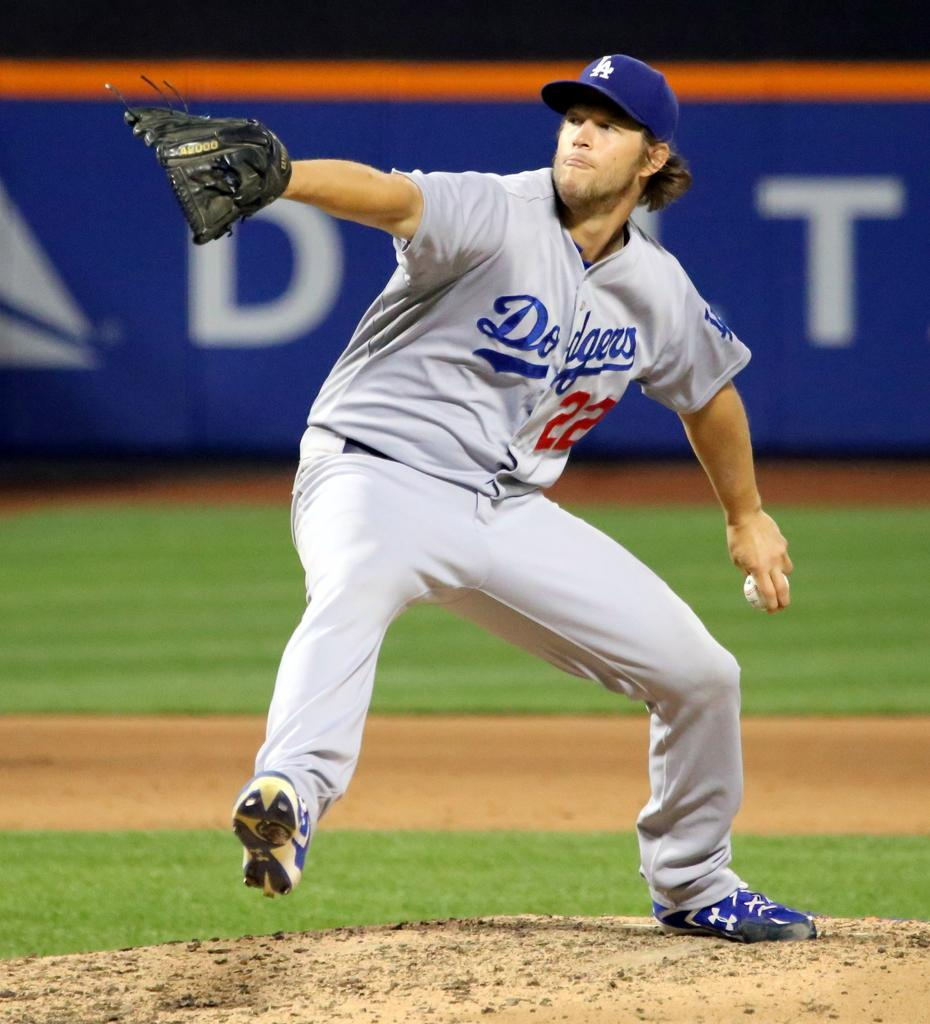<image>
Render a clear and concise summary of the photo. A dodgers player winds up to throw a pitch. 